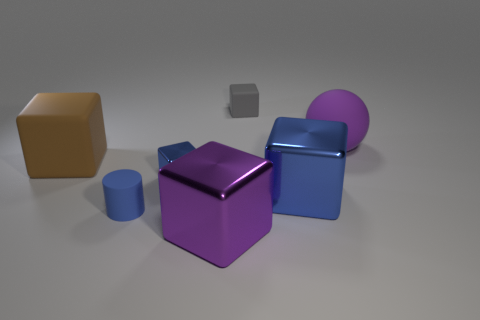Is there any other thing that has the same shape as the large purple matte thing?
Provide a succinct answer. No. Is the purple metal object the same shape as the small blue metallic thing?
Make the answer very short. Yes. Are there any other things that have the same material as the blue cylinder?
Ensure brevity in your answer.  Yes. What is the size of the purple shiny cube?
Offer a terse response. Large. The thing that is both in front of the brown object and right of the small matte block is what color?
Your response must be concise. Blue. Is the number of blue cubes greater than the number of big cyan objects?
Ensure brevity in your answer.  Yes. What number of things are tiny purple rubber cylinders or blue things left of the big blue block?
Give a very brief answer. 2. Do the gray block and the matte cylinder have the same size?
Make the answer very short. Yes. There is a big purple cube; are there any shiny cubes to the left of it?
Ensure brevity in your answer.  Yes. What is the size of the metallic thing that is right of the tiny metallic object and left of the small gray rubber object?
Provide a succinct answer. Large. 